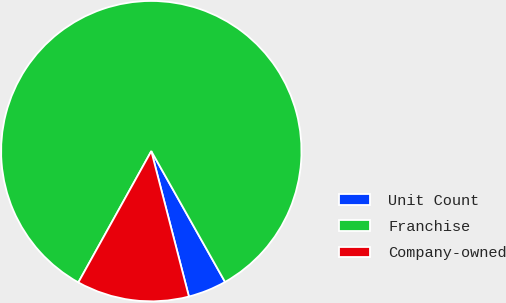Convert chart. <chart><loc_0><loc_0><loc_500><loc_500><pie_chart><fcel>Unit Count<fcel>Franchise<fcel>Company-owned<nl><fcel>4.14%<fcel>83.75%<fcel>12.1%<nl></chart> 